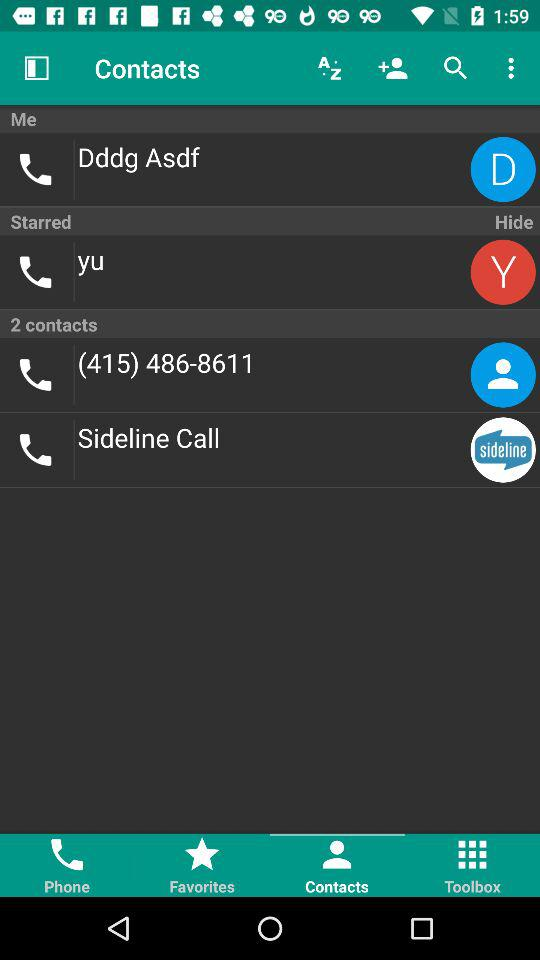Which tab is selected? The selected tab is "Contacts". 